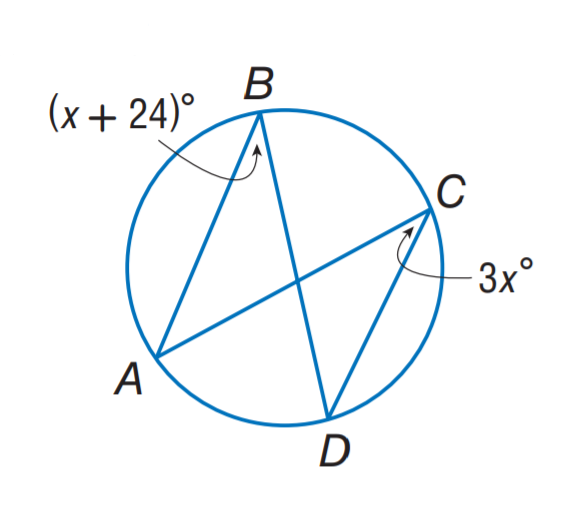Question: Find m \angle B.
Choices:
A. 24
B. 36
C. 48
D. 72
Answer with the letter. Answer: B 